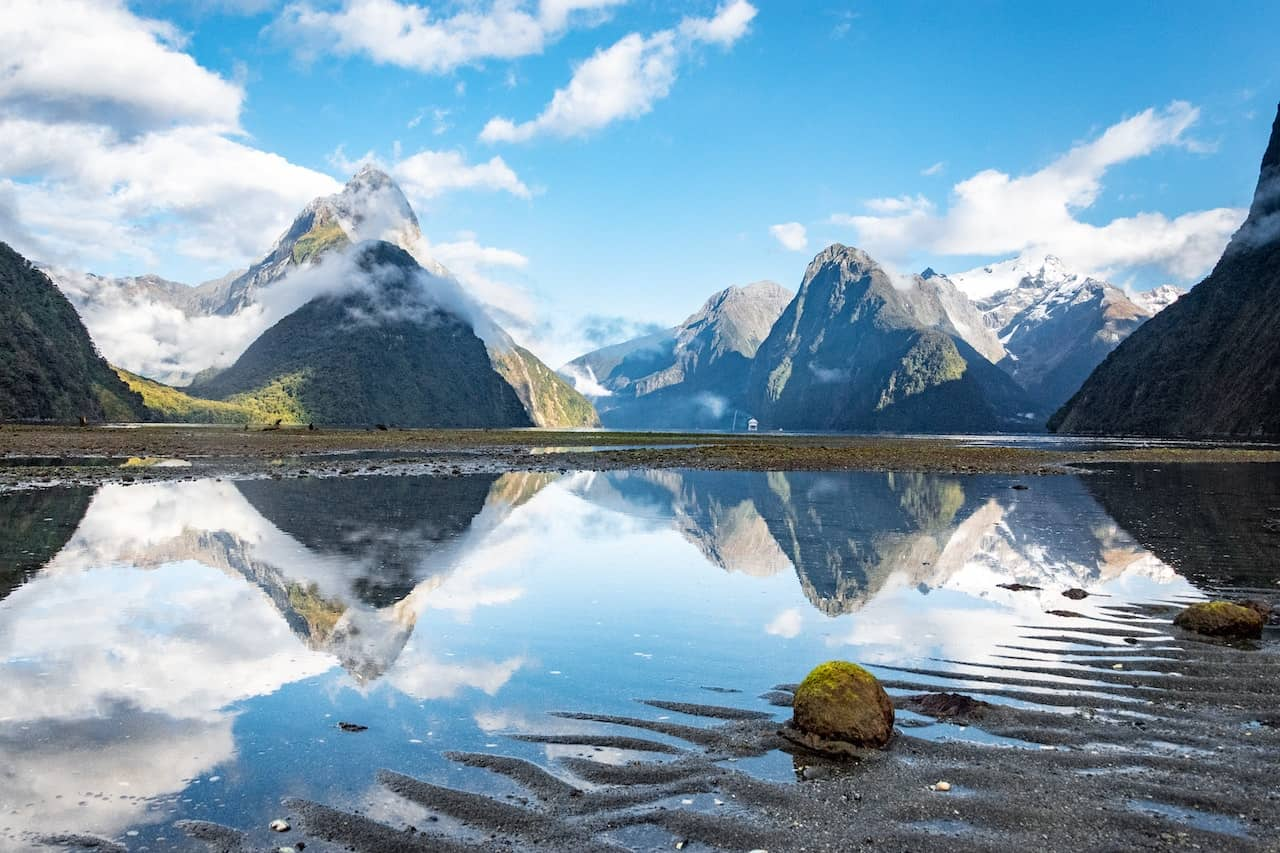What time of day does this image seem to portray, and what clues in the image lead to your conclusion? The image likely portrays mid-morning based on several visual clues. The light appears soft yet bright, indicating that the sun is not at its highest point, typically seen in early to mid-morning hours. The shadows cast are moderate, suggesting that the sun is elevated but not directly overhead. Additionally, the mist lingering around the mountains often occurs in the morning as the night's chill dissipates with the rising sun. 